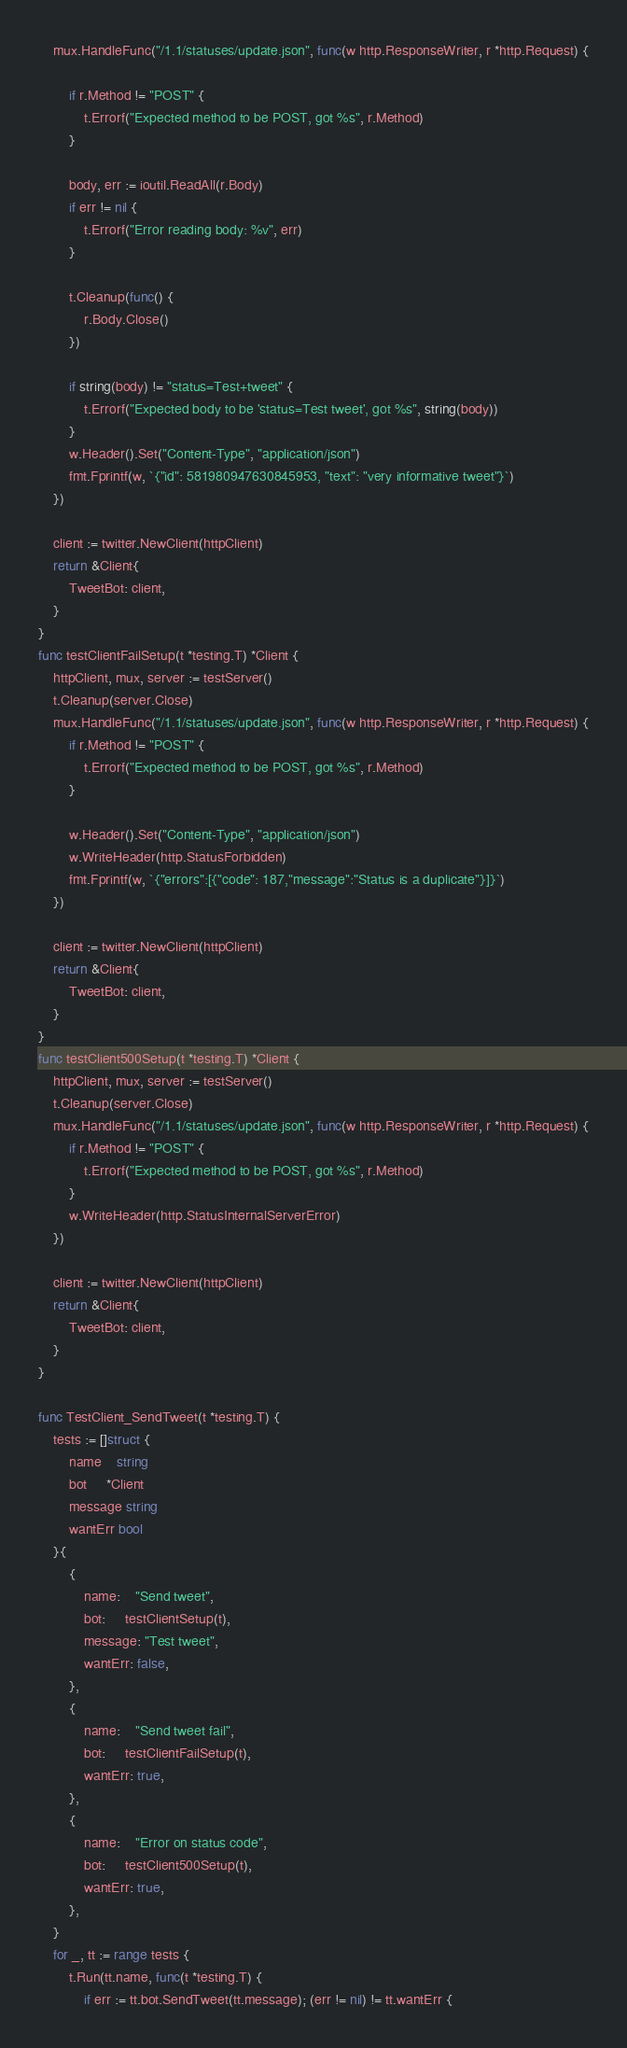Convert code to text. <code><loc_0><loc_0><loc_500><loc_500><_Go_>	mux.HandleFunc("/1.1/statuses/update.json", func(w http.ResponseWriter, r *http.Request) {

		if r.Method != "POST" {
			t.Errorf("Expected method to be POST, got %s", r.Method)
		}

		body, err := ioutil.ReadAll(r.Body)
		if err != nil {
			t.Errorf("Error reading body: %v", err)
		}

		t.Cleanup(func() {
			r.Body.Close()
		})

		if string(body) != "status=Test+tweet" {
			t.Errorf("Expected body to be 'status=Test tweet', got %s", string(body))
		}
		w.Header().Set("Content-Type", "application/json")
		fmt.Fprintf(w, `{"id": 581980947630845953, "text": "very informative tweet"}`)
	})

	client := twitter.NewClient(httpClient)
	return &Client{
		TweetBot: client,
	}
}
func testClientFailSetup(t *testing.T) *Client {
	httpClient, mux, server := testServer()
	t.Cleanup(server.Close)
	mux.HandleFunc("/1.1/statuses/update.json", func(w http.ResponseWriter, r *http.Request) {
		if r.Method != "POST" {
			t.Errorf("Expected method to be POST, got %s", r.Method)
		}

		w.Header().Set("Content-Type", "application/json")
		w.WriteHeader(http.StatusForbidden)
		fmt.Fprintf(w, `{"errors":[{"code": 187,"message":"Status is a duplicate"}]}`)
	})

	client := twitter.NewClient(httpClient)
	return &Client{
		TweetBot: client,
	}
}
func testClient500Setup(t *testing.T) *Client {
	httpClient, mux, server := testServer()
	t.Cleanup(server.Close)
	mux.HandleFunc("/1.1/statuses/update.json", func(w http.ResponseWriter, r *http.Request) {
		if r.Method != "POST" {
			t.Errorf("Expected method to be POST, got %s", r.Method)
		}
		w.WriteHeader(http.StatusInternalServerError)
	})

	client := twitter.NewClient(httpClient)
	return &Client{
		TweetBot: client,
	}
}

func TestClient_SendTweet(t *testing.T) {
	tests := []struct {
		name    string
		bot     *Client
		message string
		wantErr bool
	}{
		{
			name:    "Send tweet",
			bot:     testClientSetup(t),
			message: "Test tweet",
			wantErr: false,
		},
		{
			name:    "Send tweet fail",
			bot:     testClientFailSetup(t),
			wantErr: true,
		},
		{
			name:    "Error on status code",
			bot:     testClient500Setup(t),
			wantErr: true,
		},
	}
	for _, tt := range tests {
		t.Run(tt.name, func(t *testing.T) {
			if err := tt.bot.SendTweet(tt.message); (err != nil) != tt.wantErr {</code> 